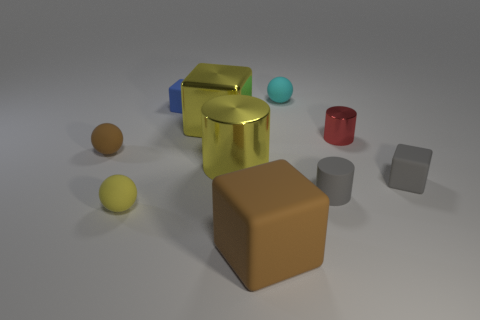There is a rubber thing that is both on the left side of the rubber cylinder and right of the large rubber block; what is its color?
Offer a terse response. Cyan. Is there a gray rubber object that has the same size as the cyan matte ball?
Keep it short and to the point. Yes. What size is the brown thing behind the rubber thing in front of the yellow matte thing?
Your answer should be very brief. Small. Are there fewer large rubber objects to the right of the gray cylinder than blue matte blocks?
Your answer should be compact. Yes. Does the large metallic cube have the same color as the big metallic cylinder?
Provide a succinct answer. Yes. How big is the yellow cylinder?
Offer a terse response. Large. What number of small metal things have the same color as the large metallic block?
Ensure brevity in your answer.  0. Is there a yellow shiny cube that is on the right side of the yellow cylinder on the left side of the metallic cylinder to the right of the large brown cube?
Keep it short and to the point. No. The blue rubber object that is the same size as the cyan sphere is what shape?
Provide a short and direct response. Cube. How many large things are blue shiny cylinders or yellow rubber spheres?
Provide a short and direct response. 0. 